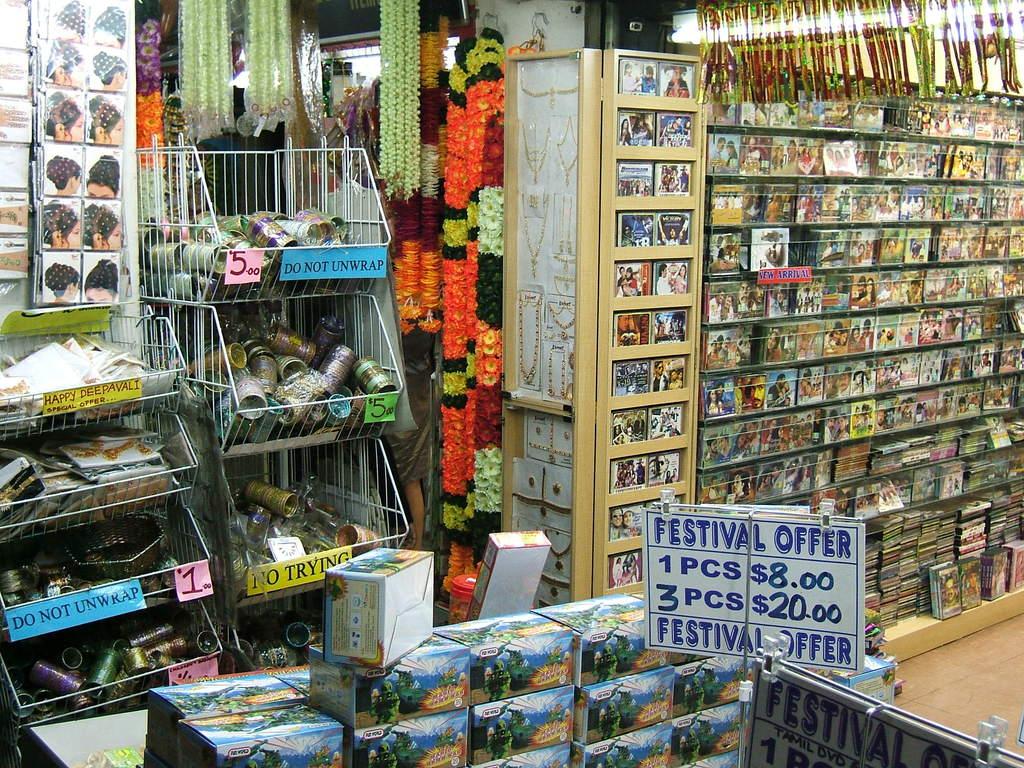How much is 1 pcs?
Your answer should be very brief. $8.00. How much for 3 pcs?
Keep it short and to the point. $20.00. 